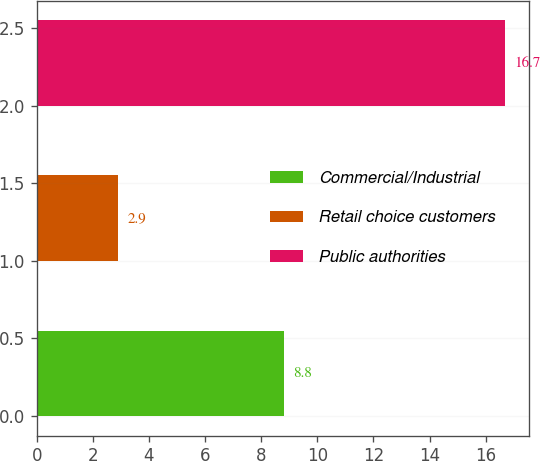Convert chart. <chart><loc_0><loc_0><loc_500><loc_500><bar_chart><fcel>Commercial/Industrial<fcel>Retail choice customers<fcel>Public authorities<nl><fcel>8.8<fcel>2.9<fcel>16.7<nl></chart> 